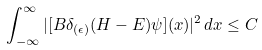Convert formula to latex. <formula><loc_0><loc_0><loc_500><loc_500>\int _ { - \infty } ^ { \infty } | [ B \delta _ { ( \epsilon ) } ( H - E ) \psi ] ( x ) | ^ { 2 } \, d x \leq C</formula> 